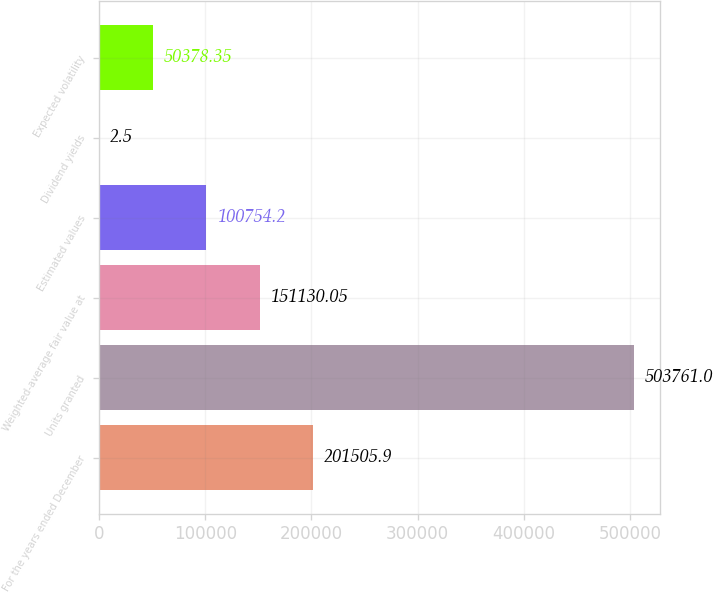<chart> <loc_0><loc_0><loc_500><loc_500><bar_chart><fcel>For the years ended December<fcel>Units granted<fcel>Weighted-average fair value at<fcel>Estimated values<fcel>Dividend yields<fcel>Expected volatility<nl><fcel>201506<fcel>503761<fcel>151130<fcel>100754<fcel>2.5<fcel>50378.3<nl></chart> 